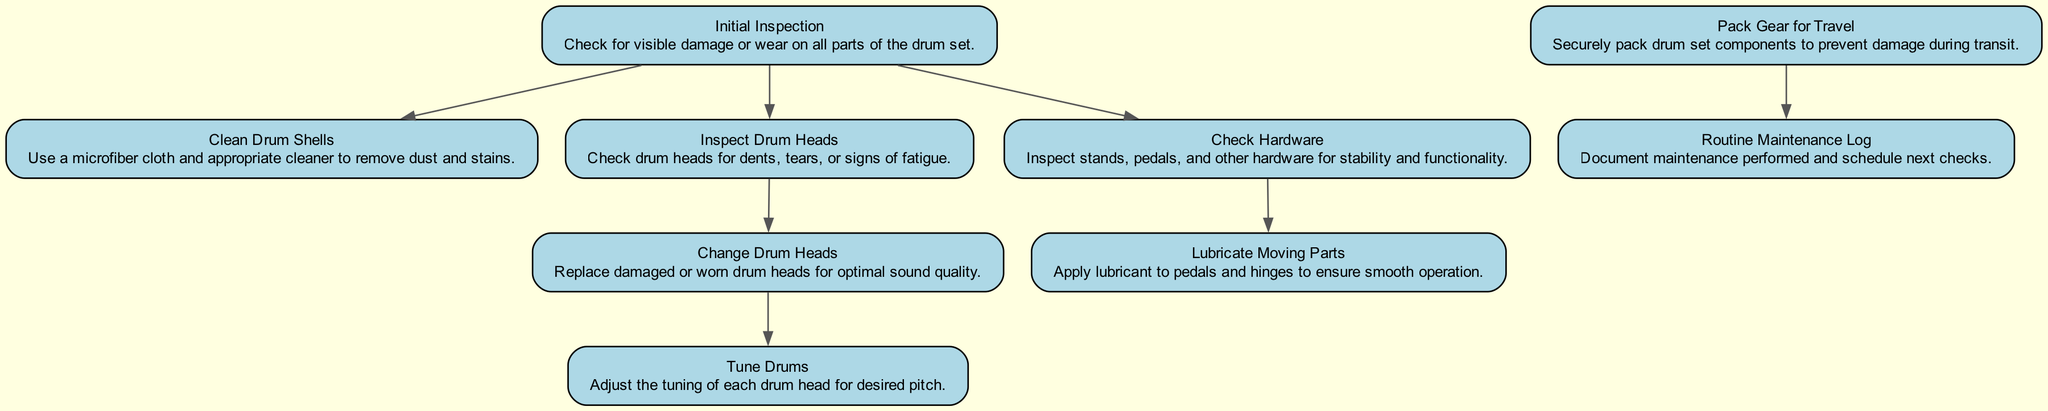What is the first step in the maintenance workflow? The initial step in the maintenance workflow, as indicated by the directed graph, is "Initial Inspection." This node is the starting point from which other tasks flow.
Answer: Initial Inspection How many nodes are in the diagram? To determine the total number of nodes, count each unique step in the maintenance workflow. There are nine specific tasks represented, from "Initial Inspection" to "Routine Maintenance Log."
Answer: 9 Which step comes after "Inspect Drum Heads"? According to the directed connections in the diagram, "Change Drum Heads" follows "Inspect Drum Heads." This indicates that after inspection, one should proceed to change any damaged heads.
Answer: Change Drum Heads What actions are taken after "Check Hardware"? The next action after "Check Hardware," as shown in the flow of the diagram, is "Lubricate Moving Parts." This indicates that once you ensure the hardware's stability, the next step involves lubrication.
Answer: Lubricate Moving Parts How many connections are there in the diagram? Connections in a directed graph represent the flow from one node to another. By counting the paths displayed, there are a total of seven connections linking the nodes together.
Answer: 7 What is the last step in the workflow? The last action outlined in the workflow is "Routine Maintenance Log." This is where all maintenance performed is documented and future checks are scheduled.
Answer: Routine Maintenance Log What is the relationship between "Initial Inspection" and "Check Hardware"? In the directed graph, "Initial Inspection" leads to "Check Hardware," indicating that after inspecting the overall condition of the drum set, one should then check the hardware.
Answer: Leads to Which two steps are directly connected before "Tune Drums"? The steps "Change Drum Heads" and "Tune Drums" are directly connected in the workflow, meaning that once you change the drum heads, the next immediate step is to tune the drums.
Answer: Change Drum Heads, Tune Drums What step must be completed before packing the gear for travel? Before "Pack Gear for Travel," the preceding step is "Routine Maintenance Log," highlighting that documenting maintenance should occur prior to preparing the gear for transit.
Answer: Routine Maintenance Log 